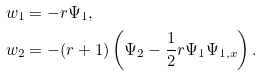Convert formula to latex. <formula><loc_0><loc_0><loc_500><loc_500>w _ { 1 } & = - r \Psi _ { 1 } , \\ w _ { 2 } & = - ( r + 1 ) \left ( \Psi _ { 2 } - \frac { 1 } { 2 } r \Psi _ { 1 } \Psi _ { 1 , x } \right ) .</formula> 